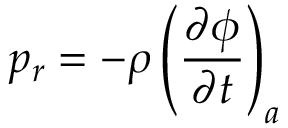Convert formula to latex. <formula><loc_0><loc_0><loc_500><loc_500>p _ { r } = - \rho \left ( \frac { \partial \phi } { \partial t } \right ) _ { a }</formula> 